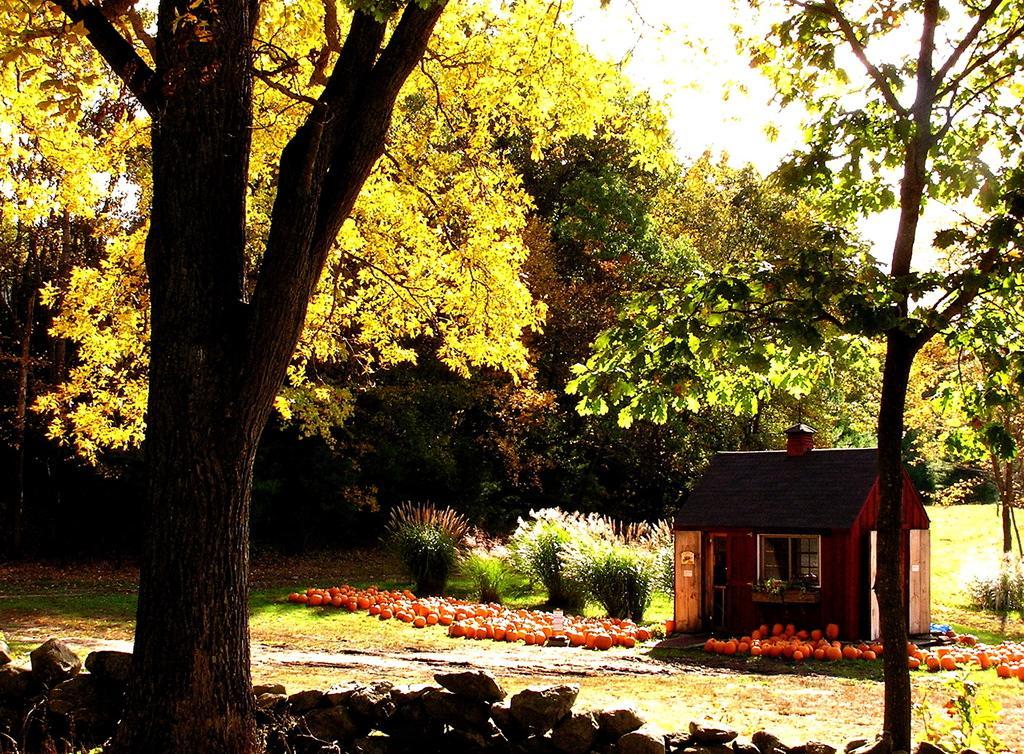Could you give a brief overview of what you see in this image? In this image I see a small house over here and I see the orange color things over here and I see the green grass, plants and number of trees and I see the stones over here. 